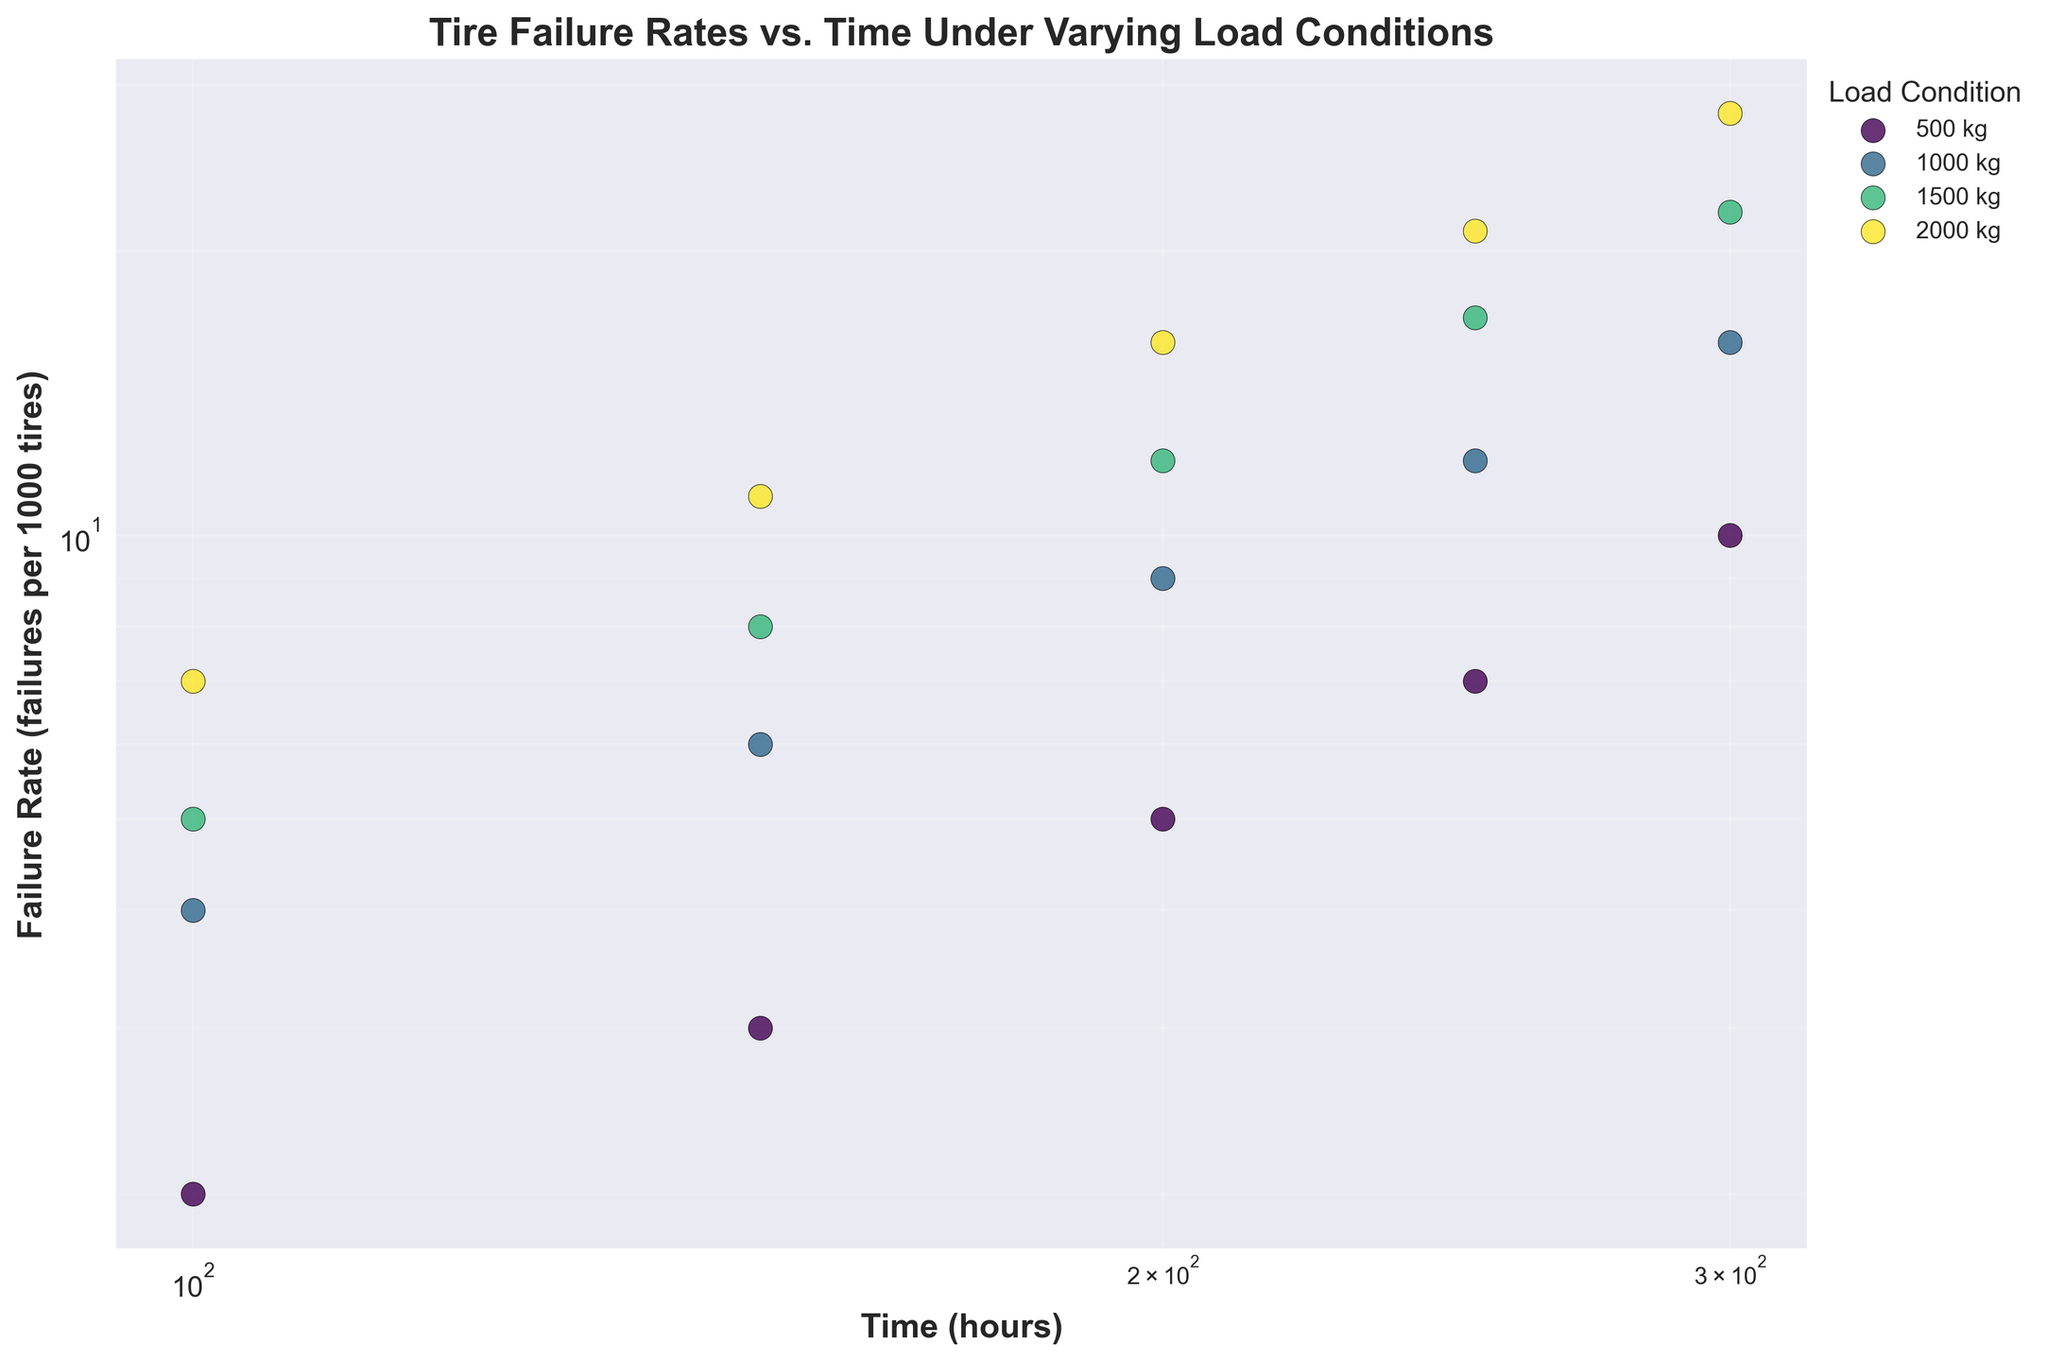Which load condition has the highest failure rate at 300 hours? To find the highest failure rate at 300 hours, identify the failure rates for each load condition at 300 hours and compare them. The failure rates at 300 hours are 10 (500 kg), 16 (1000 kg), 22 (1500 kg), and 28 (2000 kg). The highest failure rate is for the 2000 kg load condition.
Answer: 2000 kg What is the relationship between load condition and failure rate at a fixed time point like 200 hours? When comparing failure rates at 200 hours for different load conditions, the rates are 5 (500 kg), 9 (1000 kg), 12 (1500 kg), and 16 (2000 kg). This shows that as the load condition increases, the failure rate also increases.
Answer: Higher load, higher failure rate Is there any trend observable in failure rates as time increases under a fixed load condition of 1000 kg? Observe the failure rates for the 1000 kg load condition: 4 (100 hours), 6 (150 hours), 9 (200 hours), 12 (250 hours), and 16 (300 hours). The failure rate increases as time increases.
Answer: Increases with time How does the failure rate change from 100 hours to 300 hours under a load condition of 1500 kg? Look at failure rates for the 1500 kg load: 5 (100 hours), 8 (150 hours), 12 (200 hours), 17 (250 hours), and 22 (300 hours). The failure rate increases from 5 to 22 as time progresses.
Answer: Increases from 5 to 22 For which load condition is the increase in failure rate most significant from 150 to 300 hours? Compare the failure rate increases from 150 to 300 hours for all load conditions: 500 kg (3 to 10), 1000 kg (6 to 16), 1500 kg (8 to 22), 2000 kg (11 to 28). The most significant increase is for the 2000 kg load condition, from 11 to 28.
Answer: 2000 kg What is the failure rate difference between 100 hours and 200 hours under 500 kg load condition? Calculate the difference between the failure rates at 100 hours (2 failures per 1000 tires) and 200 hours (5 failures per 1000 tires) under 500 kg load. The difference is 5 - 2 = 3 failures per 1000 tires.
Answer: 3 Are there any load conditions that have overlapping failure rates within the same time point? Review the failure rates for each time point across load conditions to see if any overlap. At 100 hours: 2 (500 kg), 4 (1000 kg), 5 (1500 kg), 7 (2000 kg). No overlaps are observed.
Answer: No How does the failure rate increase proportionally as load increases at 200 hours? Look at failure rates at 200 hours: 5 (500 kg), 9 (1000 kg), 12 (1500 kg), 16 (2000 kg). The increase from 500 to 1000 kg is 4, from 1000 to 1500 kg is 3, and from 1500 to 2000 kg is 4. The rate of increase is not perfectly proportional.
Answer: Not proportional 